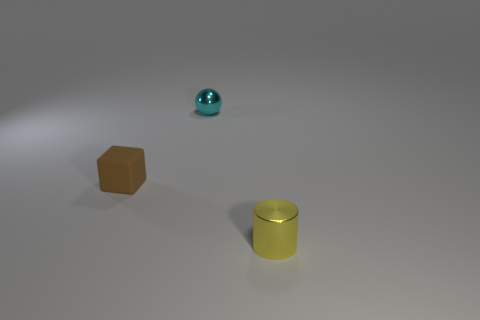How many things are large brown metallic cubes or metal objects?
Make the answer very short. 2. How many small yellow shiny objects are on the left side of the tiny metallic thing that is on the left side of the small thing on the right side of the metallic sphere?
Offer a terse response. 0. There is a tiny object that is to the left of the tiny yellow thing and right of the tiny brown rubber cube; what is its material?
Your answer should be very brief. Metal. Is the number of rubber things that are behind the tiny brown rubber thing less than the number of small shiny cylinders that are on the right side of the small cyan thing?
Offer a very short reply. Yes. What number of other objects are the same size as the brown matte cube?
Ensure brevity in your answer.  2. There is a metal thing in front of the tiny thing that is left of the metal thing behind the small yellow cylinder; what is its shape?
Your response must be concise. Cylinder. How many green things are shiny things or balls?
Provide a succinct answer. 0. There is a small thing on the right side of the cyan ball; how many small cyan metallic balls are behind it?
Keep it short and to the point. 1. Is there anything else that has the same color as the small ball?
Give a very brief answer. No. The small yellow object that is the same material as the small cyan object is what shape?
Offer a terse response. Cylinder. 